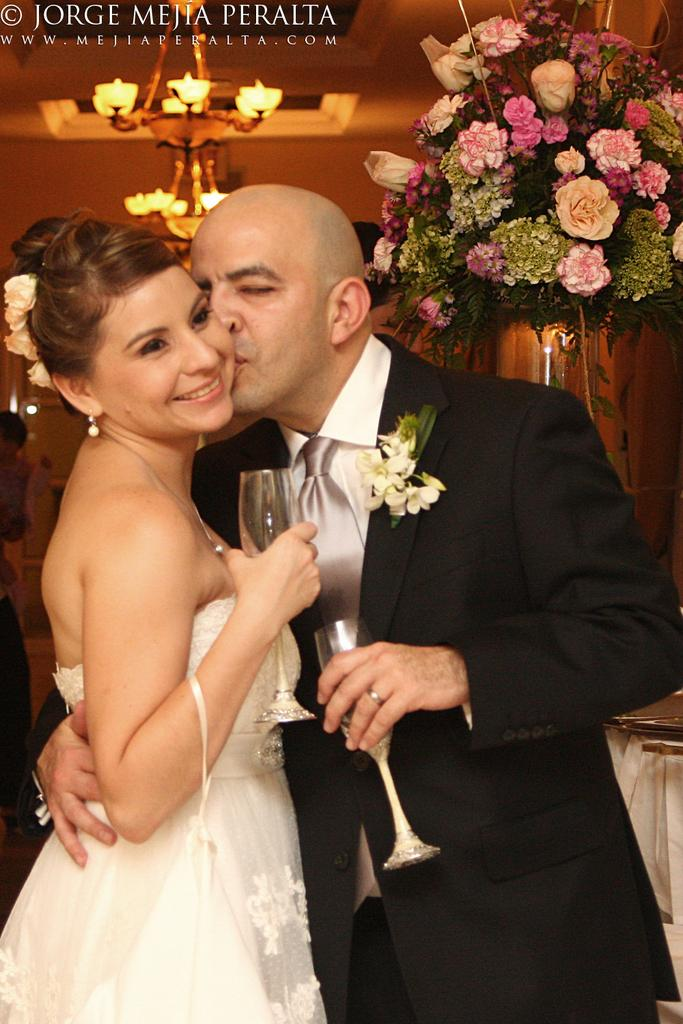What is the man in the image wearing? The man in the image is wearing a blazer. What is the man doing with the girl in the image? The man is holding a girl and they are kissing. What is the girl wearing that is typically associated with boys' clothing? The girl is wearing a tie. What are the man and the girl holding in their hands? Both the man and the girl are holding glasses in their hands. What can be seen in the background of the image? There is a chandelier and flowers in the background of the image. What is the temperature outside during the summer in the image? The provided facts do not mention the temperature or the season, so it cannot be determined from the image. 